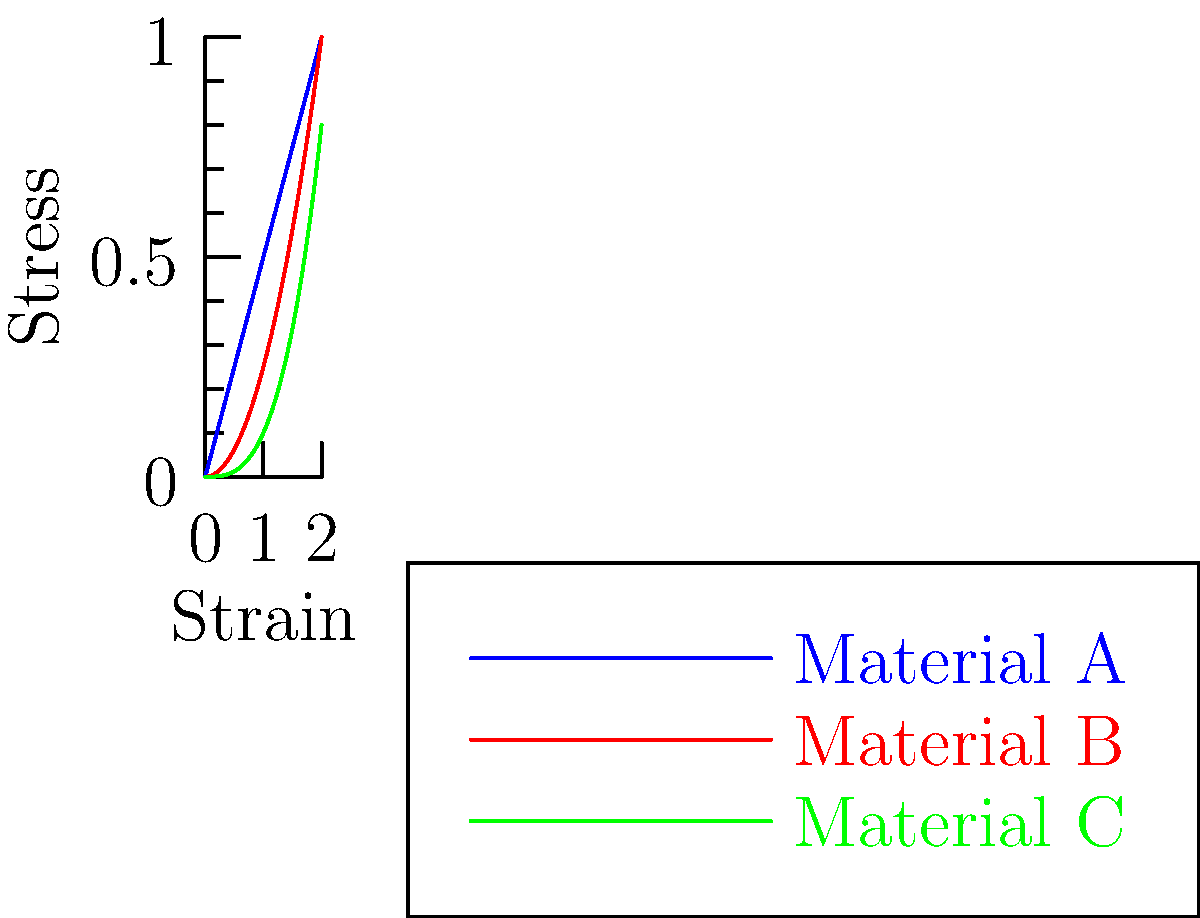As a researcher studying protein-protein interactions, you're analyzing the mechanical properties of different cellular components. The stress-strain curves for three materials (A, B, and C) are shown above. Which material exhibits the most non-linear behavior, and how might this relate to the behavior of certain protein structures under stress? To answer this question, we need to analyze the stress-strain curves for each material:

1. Material A (blue line): This shows a linear relationship between stress and strain, indicating a constant slope or elastic modulus. This is typical of materials that obey Hooke's law.

2. Material B (red line): This curve is slightly non-linear, showing an increasing slope as strain increases. This indicates some degree of strain hardening.

3. Material C (green line): This curve shows the most pronounced non-linear behavior, with a rapidly increasing slope as strain increases. This suggests significant strain hardening or possibly a complex molecular structure.

Material C exhibits the most non-linear behavior among the three materials. In the context of protein structures, this non-linear behavior could relate to:

1. Unfolding of protein domains: As stress increases, different structural elements of a protein might unfold sequentially, leading to a non-linear response.

2. Conformational changes: Some proteins undergo significant conformational changes under stress, which can result in non-linear stress-strain relationships.

3. Complex molecular interactions: In multi-domain proteins or protein complexes, the interactions between different parts of the structure might lead to complex, non-linear responses to stress.

4. Strain-induced strengthening: Some protein structures, like cytoskeletal components, can exhibit strain hardening, where they become stiffer as they are stretched.

This non-linear behavior is particularly relevant in cellular mechanics, where proteins often need to respond dynamically to varying mechanical stimuli.
Answer: Material C; relates to protein unfolding, conformational changes, complex interactions, and strain-induced strengthening in cellular structures. 